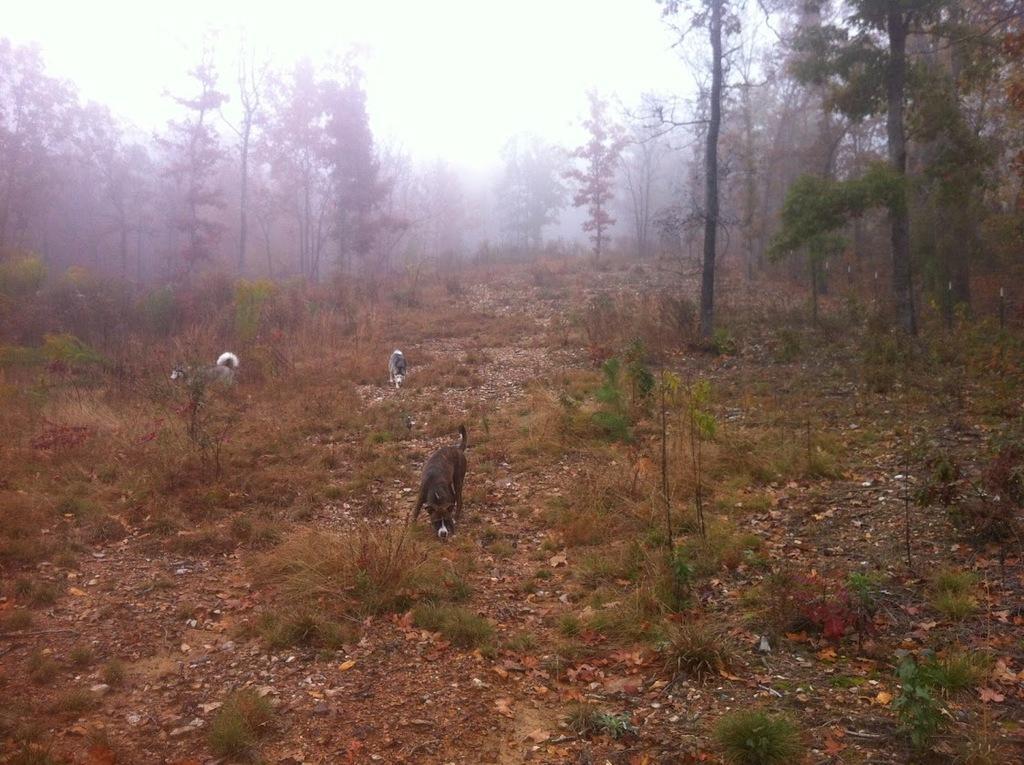Could you give a brief overview of what you see in this image? In this image there are trees and we can see animals. At the bottom there is grass. In the background there is sky. 